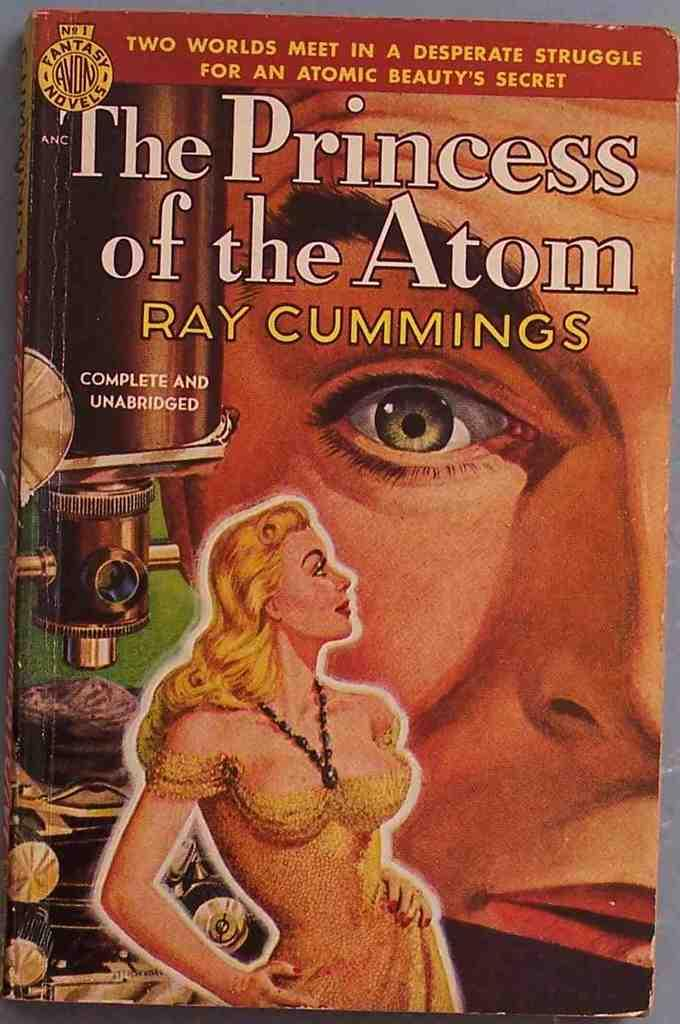Provide a one-sentence caption for the provided image. The Princess of the Atom, written by Ray Cummings, is shown in its unabridged version. 